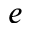Convert formula to latex. <formula><loc_0><loc_0><loc_500><loc_500>e</formula> 